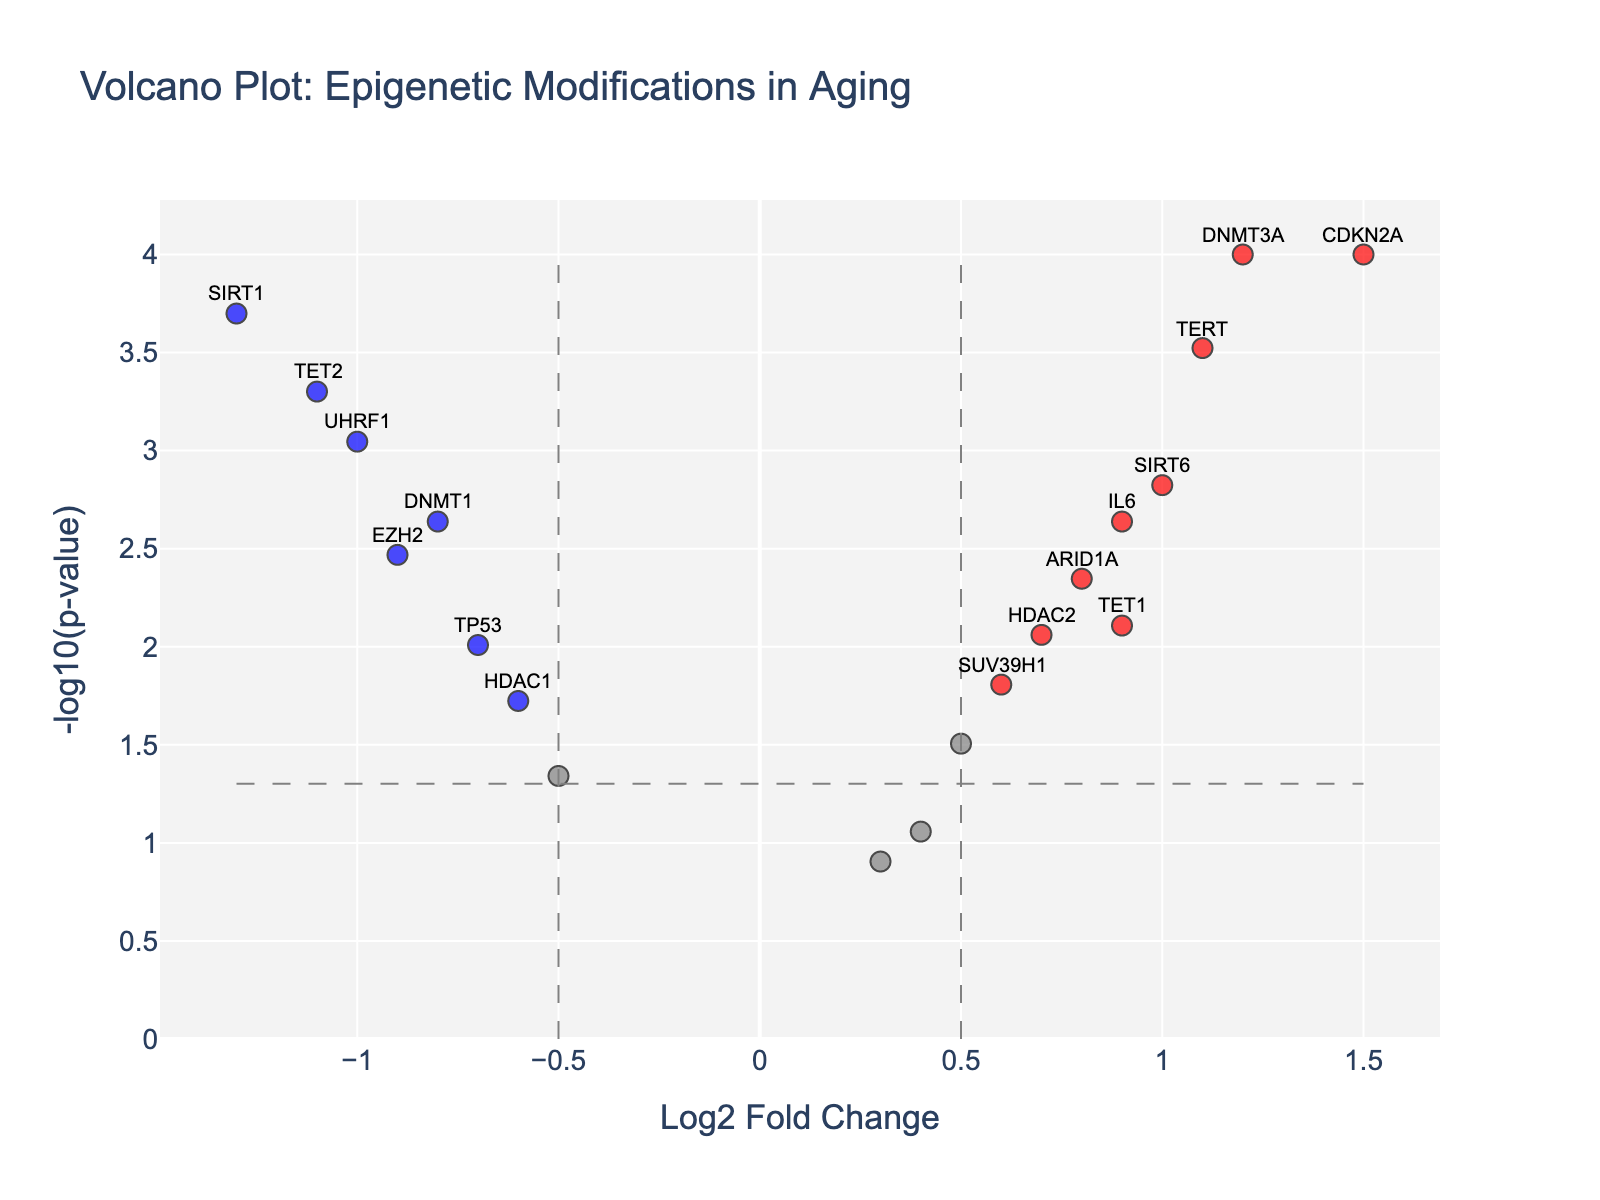What's the title of the figure? The figure's title is written at the top, usually in a larger font size compared to other text elements on the figure.
Answer: Volcano Plot: Epigenetic Modifications in Aging What are the axes labels? The labels are usually found along the edges of each axis. The x-axis label is "Log2 Fold Change" and the y-axis label is "-log10(p-value)".
Answer: Log2 Fold Change, -log10(p-value) How many genes are classified as significant based on the color coding? Significant genes are those marked in red and blue, indicating they meet both the p-value and fold change thresholds. By counting these dots, we can determine the number of significant genes.
Answer: 11 Which gene has the highest log2 fold change? To identify this, look along the x-axis (Log2 Fold Change) for the furthest right point and note the gene labeled.
Answer: CDKN2A Which gene has the most substantial negative log2 fold change? Negative log2 fold change would be represented by points farthest to the left on the x-axis. Note the label of the leftmost point.
Answer: SIRT1 What is the p-value threshold used in this plot? The p-value threshold can be determined by examining where the horizontal dashed line, representing p = 0.05, intersects the y-axis. The y-axis label at this point indicates -log10(0.05). This value is approximately 1.3.
Answer: 0.05 Which genes have a p-value less than 0.01 and a log2 fold change greater than 1? Look for red or blue dots above the y = 2 threshold that are positioned to the right of x = 1. Read their gene labels. TERT and CDKN2A are both labeled here.
Answer: TERT, CDKN2A How many genes have both a log2 fold change between -0.5 and 0.5 and a p-value greater than 0.05? Genes with log2 fold change between -0.5 and 0.5 are in the middle of the plot (x-axis). Those with p-value greater than 0.05 are not meeting the y-axis threshold of -log10(0.05). We need to count these dots in the specified region.
Answer: 1 Which gene has the highest p-value? To find this, identify the point with the smallest y-axis value (lowest vertical position). The gene label for this point denotes the highest p-value.
Answer: MECP2 What is the fold change threshold used in this plot? The fold change threshold can be identified by examining where the two vertical dashed lines intersect the x-axis. The x-axis label at these points likely signifies -0.5 and 0.5.
Answer: 0.5 